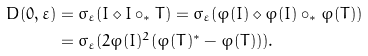Convert formula to latex. <formula><loc_0><loc_0><loc_500><loc_500>D ( 0 , \varepsilon ) & = \sigma _ { \varepsilon } ( I \diamond I \circ _ { \ast } T ) = \sigma _ { \varepsilon } ( \varphi ( I ) \diamond \varphi ( I ) \circ _ { \ast } \varphi ( T ) ) \\ & = \sigma _ { \varepsilon } ( 2 \varphi ( I ) ^ { 2 } ( \varphi ( T ) ^ { \ast } - \varphi ( T ) ) ) .</formula> 